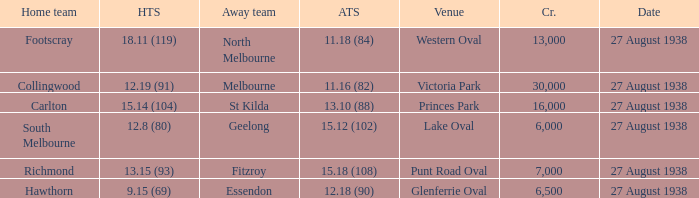Which home team had the away team score 15.18 (108) against them? 13.15 (93). 